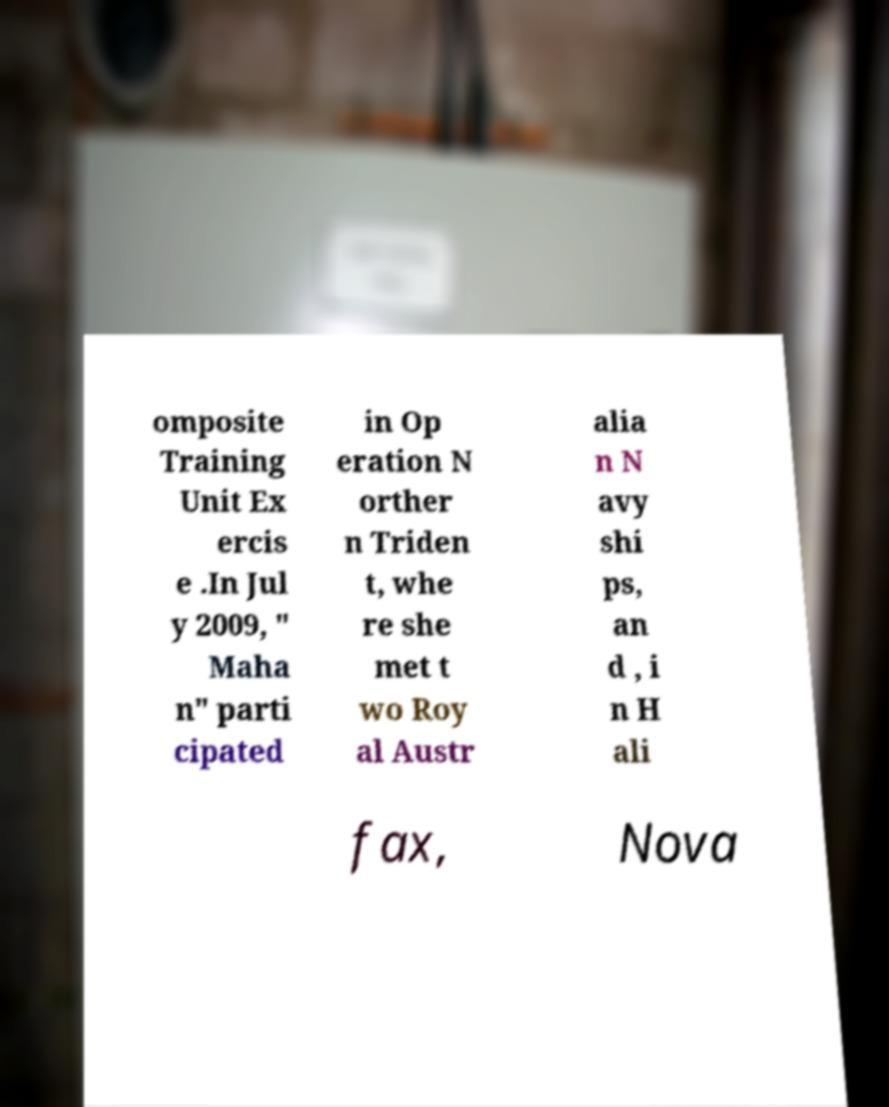Can you accurately transcribe the text from the provided image for me? omposite Training Unit Ex ercis e .In Jul y 2009, " Maha n" parti cipated in Op eration N orther n Triden t, whe re she met t wo Roy al Austr alia n N avy shi ps, an d , i n H ali fax, Nova 